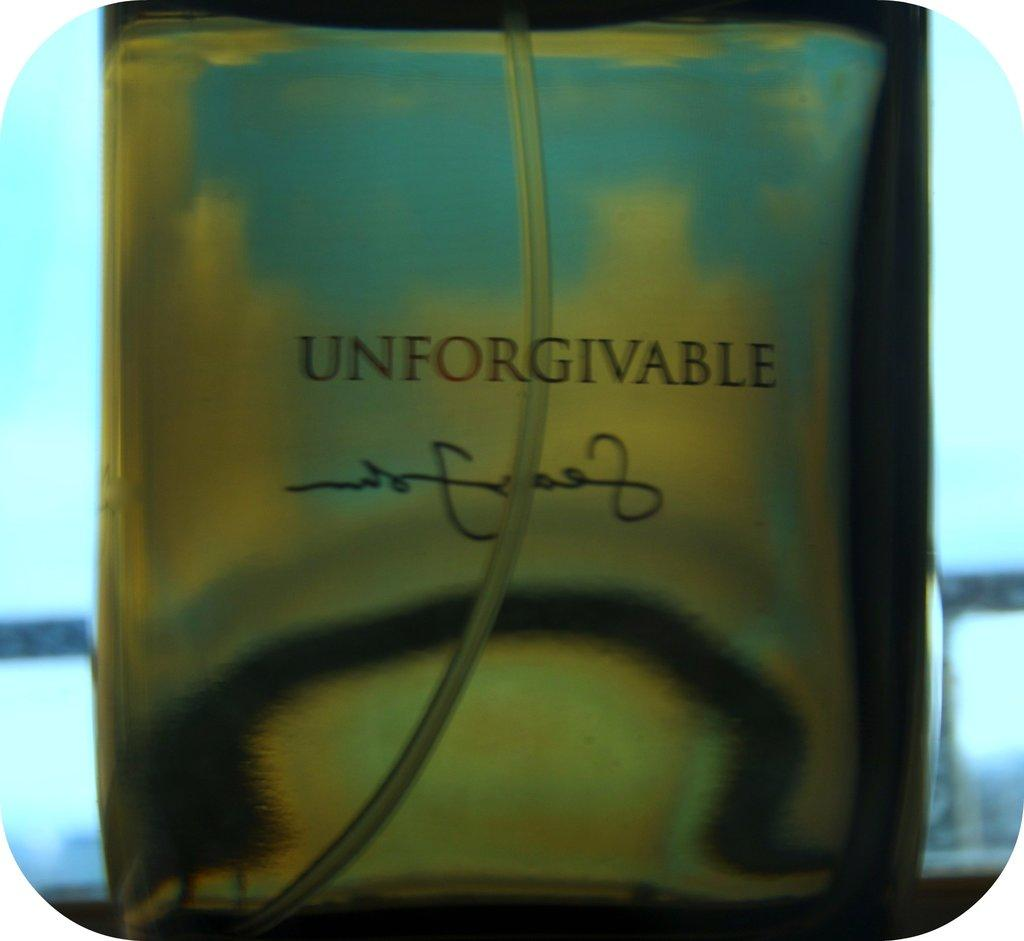<image>
Share a concise interpretation of the image provided. The bottle of perfume shown is called Unforgivable. 